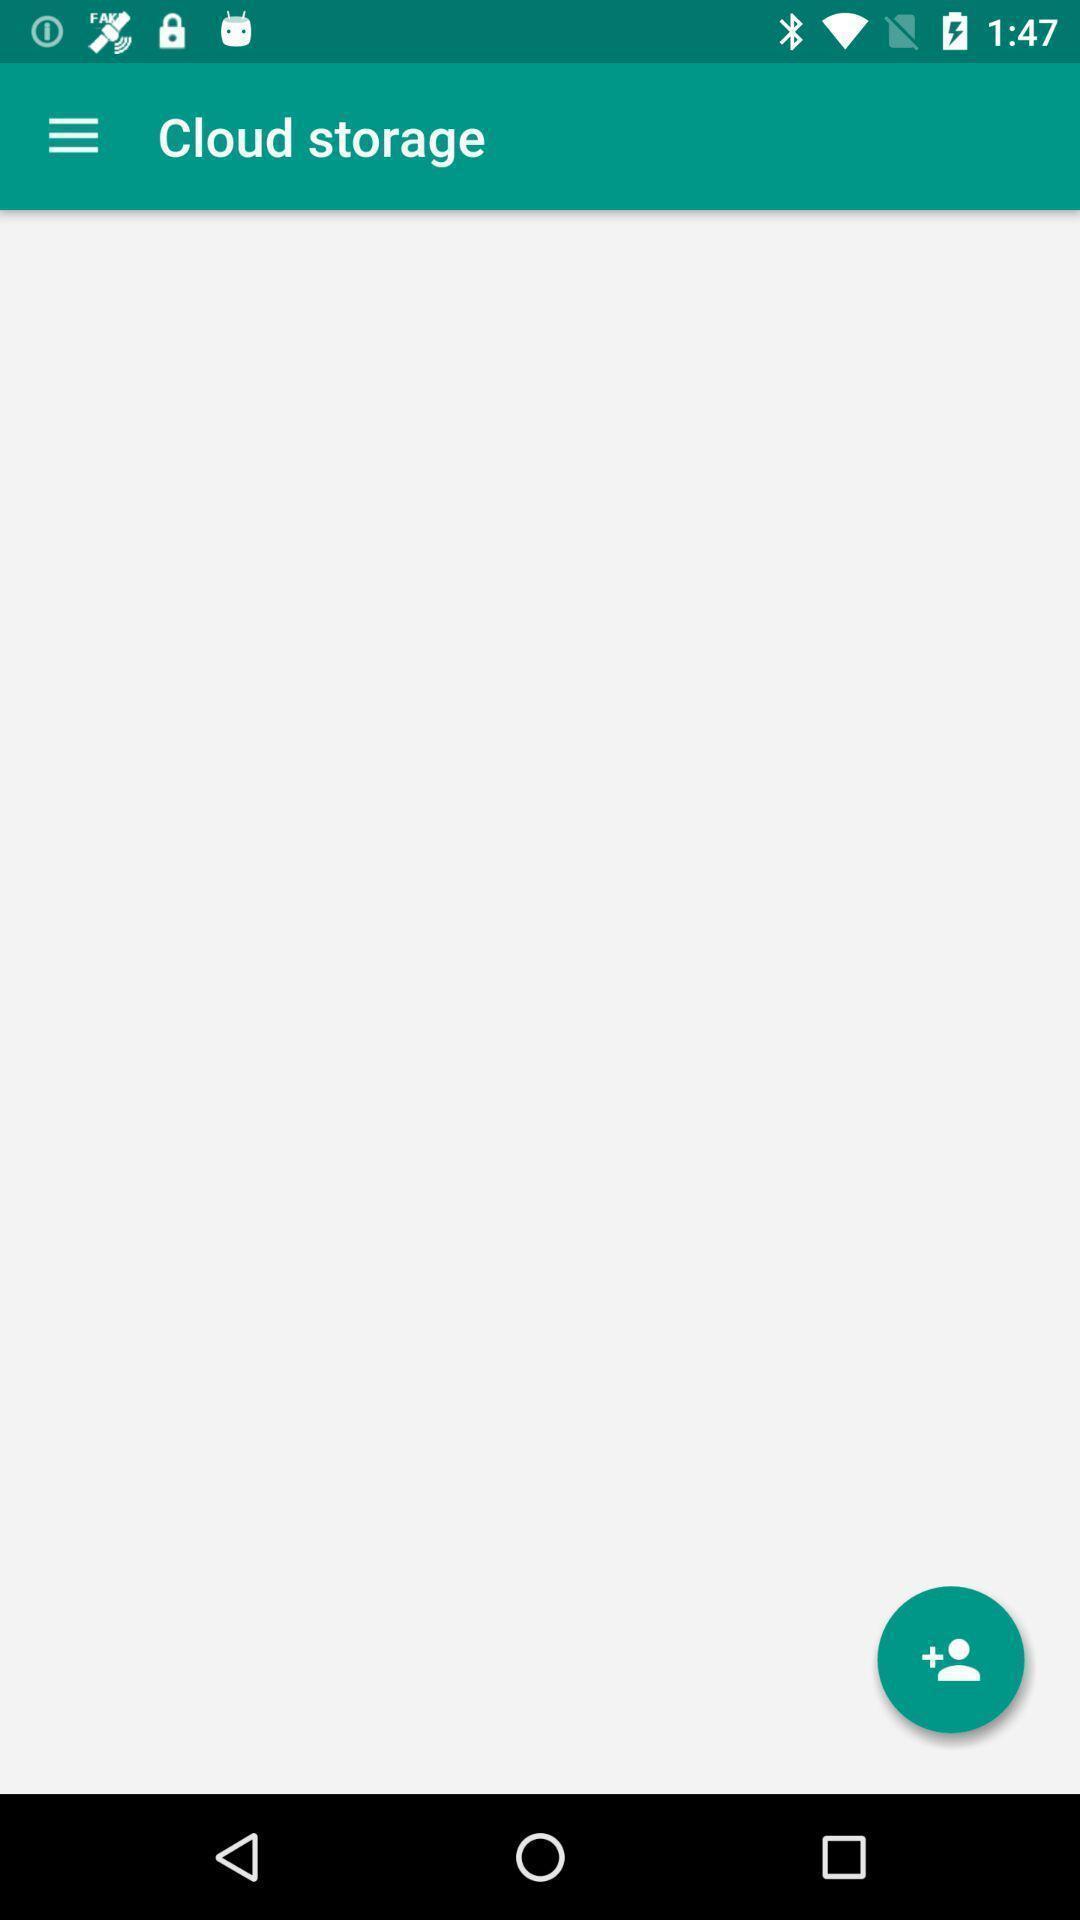Describe the key features of this screenshot. Screen showing cloud storage page. 